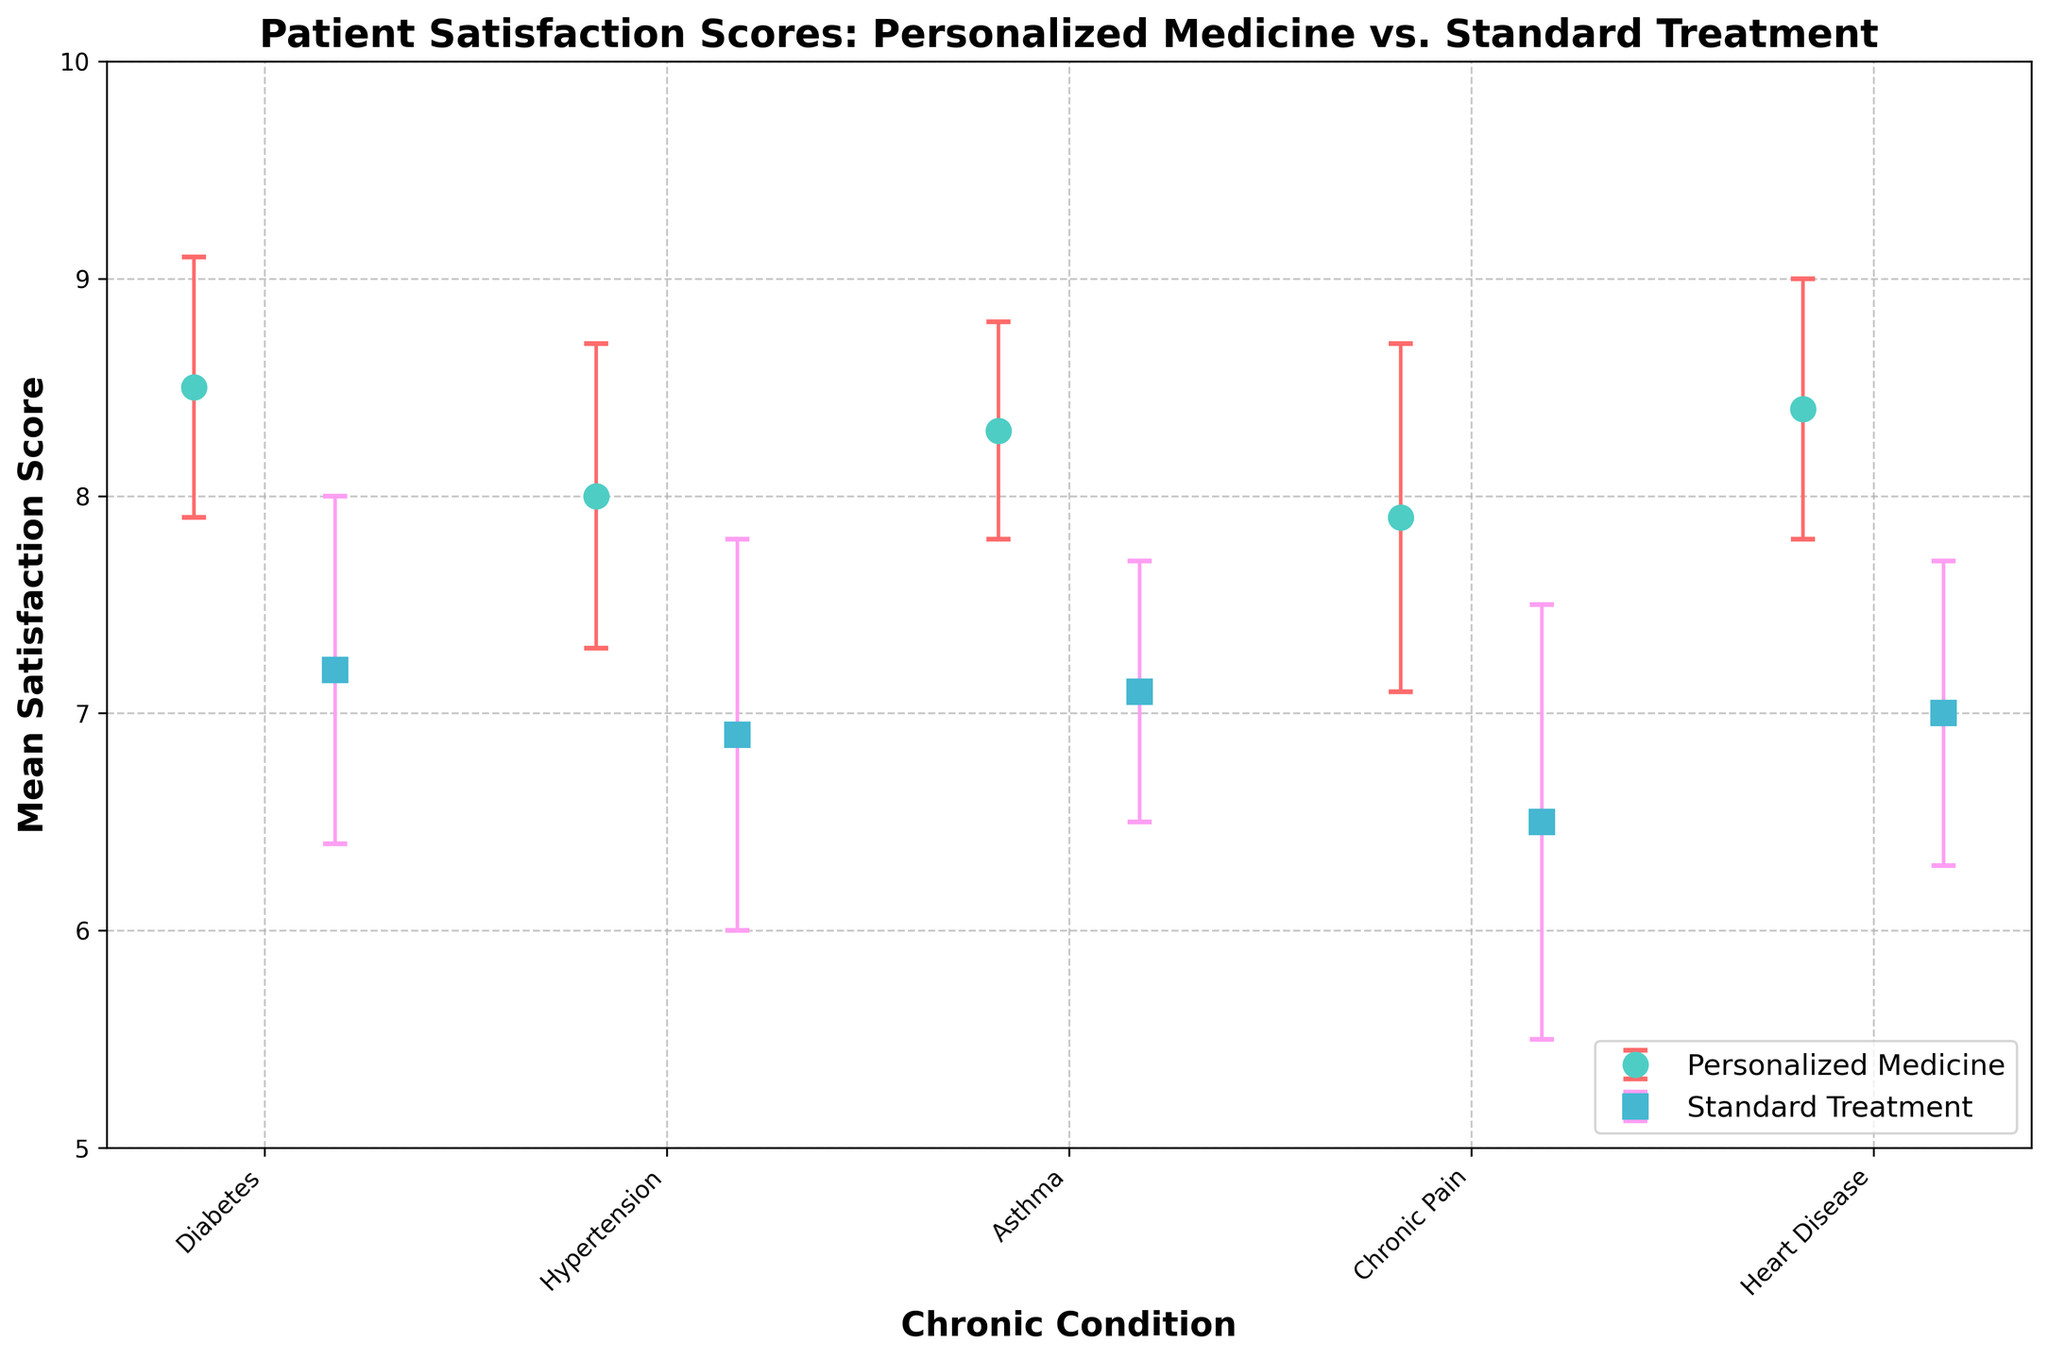What is the title of the figure? The title is typically displayed at the top of the figure. It provides a description of what the graph is about. Here, it states the comparison of patient satisfaction scores between personalized medicine and standard treatment across different chronic conditions.
Answer: Patient Satisfaction Scores: Personalized Medicine vs. Standard Treatment What is the mean satisfaction score for patients with diabetes using personalized medicine? For each chronic condition, there are two data points for mean satisfaction scores, represented by different markers. The mean satisfaction score for diabetes and personalized medicine can be directly read off the appropriate marker.
Answer: 8.5 What is the lowest satisfaction score reported, and for which group and condition? By examining all the data points, the lowest satisfaction score and its corresponding group and condition are identified.
Answer: Standard Treatment for Chronic Pain, 6.5 Which chronic condition shows the largest difference in mean satisfaction scores between personalized medicine and standard treatment? Calculate the difference between the mean satisfaction scores of personalized medicine and standard treatment for each chronic condition. Compare these differences to determine the largest one.
Answer: Chronic Pain: 7.9 - 6.5 = 1.4 Which treatment group generally shows higher satisfaction scores across all chronic conditions? Compare the mean satisfaction scores for personalized medicine and standard treatment across all chronic conditions. Identify which group consistently has higher scores.
Answer: Personalized Medicine What is the error bar range for personalized medicine in hypertension? Identify the error bar (standard deviation) for personalized medicine in hypertension, which provides a range around the mean satisfaction score.
Answer: 8.0 ± 0.7 For which condition is the satisfaction score most variable under standard treatment? Variability is indicated by the size of the error bars. By comparing the error bars for standard treatment across all conditions, the largest error bar determines the most variability.
Answer: Chronic Pain (± 1.0) What is the average satisfaction score for personalized medicine across all conditions? Calculate the average of the mean satisfaction scores for personalized medicine across all chronic conditions. Sum the scores and divide by the number of conditions.
Answer: (8.5 + 8.0 + 8.3 + 7.9 + 8.4) / 5 = 8.22 How does the satisfaction score for asthma using standard treatment compare to the mean score for all conditions using personalized medicine? Compare the satisfaction score for asthma using standard treatment to the average satisfaction score for personalized medicine across all conditions.
Answer: 7.1 vs 8.22, asthma (standard treatment) is lower In which condition does personalized medicine have the smallest mean satisfaction score? Identify the smallest mean satisfaction score from the personalized medicine data points for all chronic conditions.
Answer: Chronic Pain (7.9) 